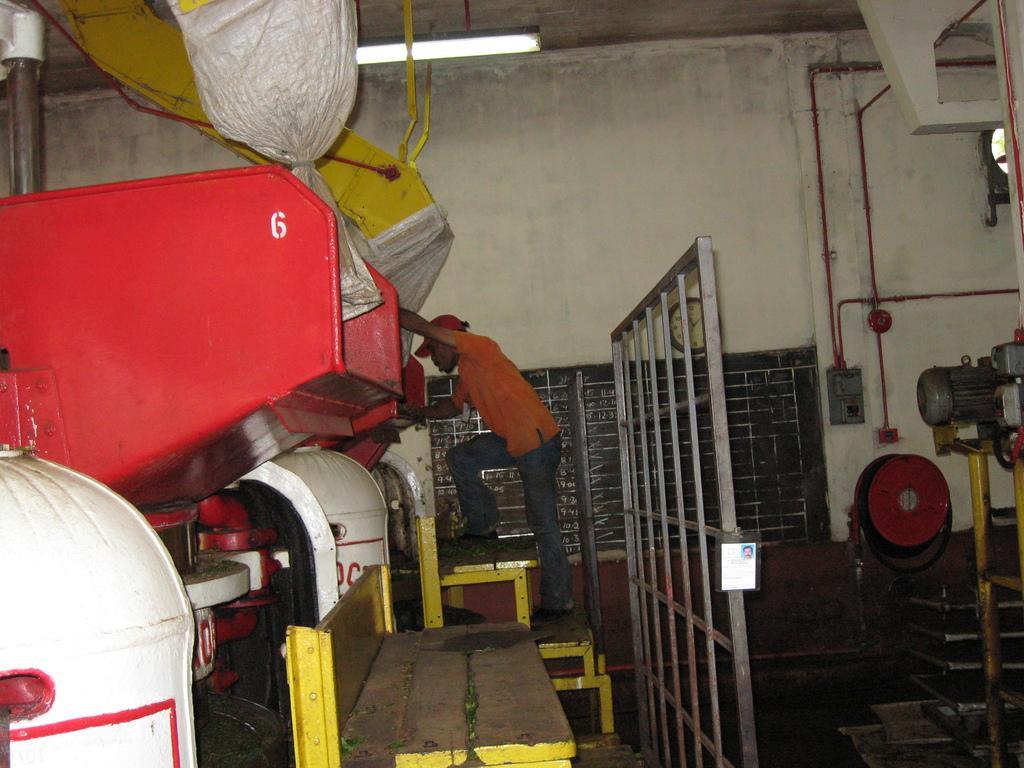Describe this image in one or two sentences. In this image there is a man standing on the wooden steps and looking in to the machines which are in front of him. On the right side there are motors and pipes. In the middle there is an iron grill. In the background there are pipes which are attached to the wall. At the bottom there is a wooden bench. 